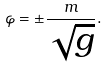<formula> <loc_0><loc_0><loc_500><loc_500>\varphi = \pm \frac { m } { \sqrt { g } } .</formula> 